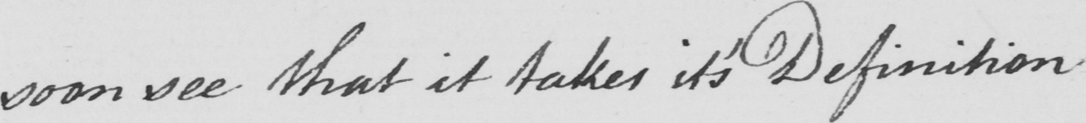Please transcribe the handwritten text in this image. soon see that it takes it ' s Definition . 